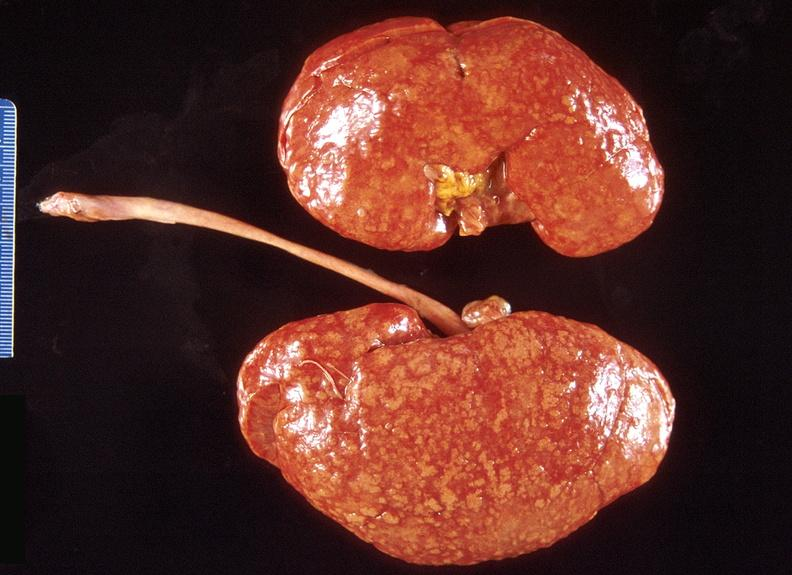where is this?
Answer the question using a single word or phrase. Urinary 